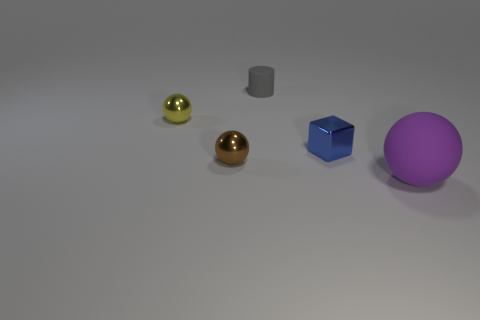Subtract all shiny spheres. How many spheres are left? 1 Subtract all cubes. How many objects are left? 4 Subtract 2 balls. How many balls are left? 1 Subtract all gray blocks. Subtract all brown cylinders. How many blocks are left? 1 Subtract all cyan blocks. How many blue cylinders are left? 0 Subtract all cylinders. Subtract all tiny cylinders. How many objects are left? 3 Add 5 tiny spheres. How many tiny spheres are left? 7 Add 1 large matte things. How many large matte things exist? 2 Add 4 big purple things. How many objects exist? 9 Subtract 0 red blocks. How many objects are left? 5 